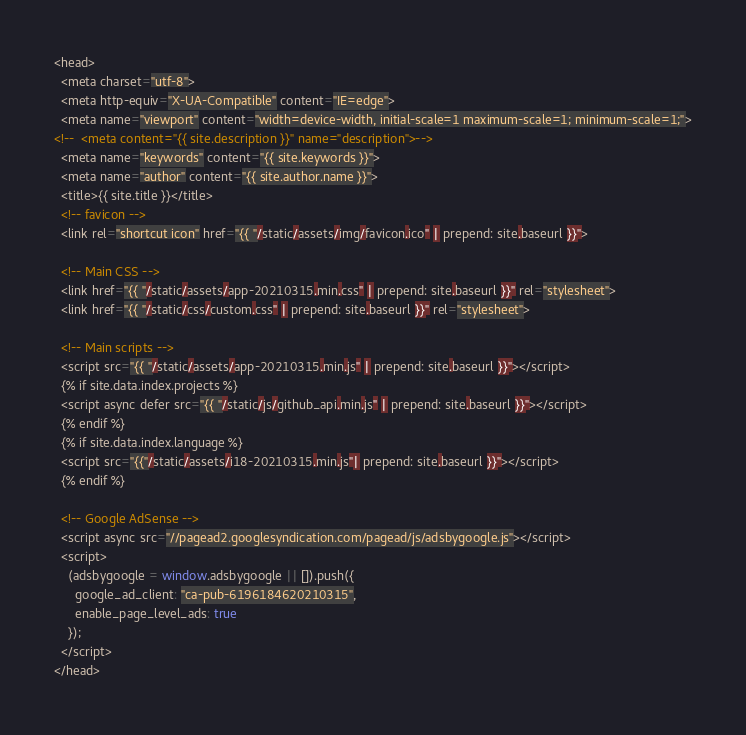Convert code to text. <code><loc_0><loc_0><loc_500><loc_500><_HTML_><head>
  <meta charset="utf-8">
  <meta http-equiv="X-UA-Compatible" content="IE=edge">
  <meta name="viewport" content="width=device-width, initial-scale=1 maximum-scale=1; minimum-scale=1;">
<!--  <meta content="{{ site.description }}" name="description">-->
  <meta name="keywords" content="{{ site.keywords }}">
  <meta name="author" content="{{ site.author.name }}">
  <title>{{ site.title }}</title>
  <!-- favicon -->
  <link rel="shortcut icon" href="{{ "/static/assets/img/favicon.ico" | prepend: site.baseurl }}">

  <!-- Main CSS -->
  <link href="{{ "/static/assets/app-20210315.min.css" | prepend: site.baseurl }}" rel="stylesheet">
  <link href="{{ "/static/css/custom.css" | prepend: site.baseurl }}" rel="stylesheet">

  <!-- Main scripts -->
  <script src="{{ "/static/assets/app-20210315.min.js" | prepend: site.baseurl }}"></script>
  {% if site.data.index.projects %}
  <script async defer src="{{ "/static/js/github_api.min.js" | prepend: site.baseurl }}"></script>
  {% endif %}
  {% if site.data.index.language %}
  <script src="{{"/static/assets/i18-20210315.min.js"| prepend: site.baseurl }}"></script>
  {% endif %}

  <!-- Google AdSense -->
  <script async src="//pagead2.googlesyndication.com/pagead/js/adsbygoogle.js"></script>
  <script>
    (adsbygoogle = window.adsbygoogle || []).push({
      google_ad_client: "ca-pub-6196184620210315",
      enable_page_level_ads: true
    });
  </script>
</head>
</code> 